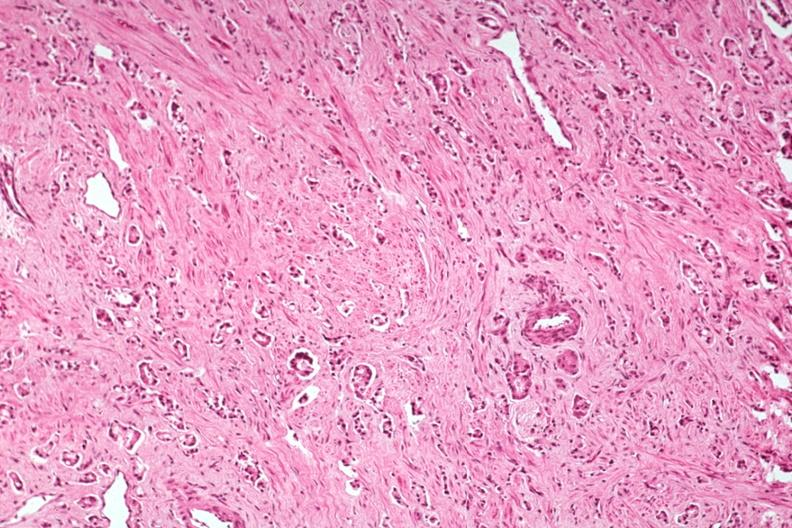does this image show med typical prostate cancer good example?
Answer the question using a single word or phrase. Yes 